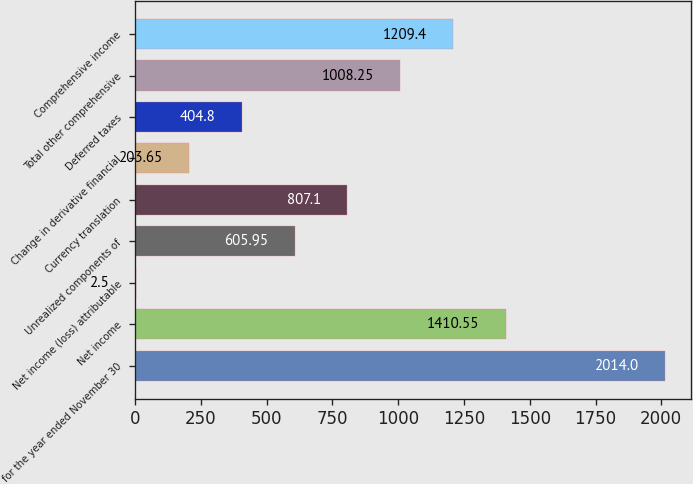Convert chart. <chart><loc_0><loc_0><loc_500><loc_500><bar_chart><fcel>for the year ended November 30<fcel>Net income<fcel>Net income (loss) attributable<fcel>Unrealized components of<fcel>Currency translation<fcel>Change in derivative financial<fcel>Deferred taxes<fcel>Total other comprehensive<fcel>Comprehensive income<nl><fcel>2014<fcel>1410.55<fcel>2.5<fcel>605.95<fcel>807.1<fcel>203.65<fcel>404.8<fcel>1008.25<fcel>1209.4<nl></chart> 